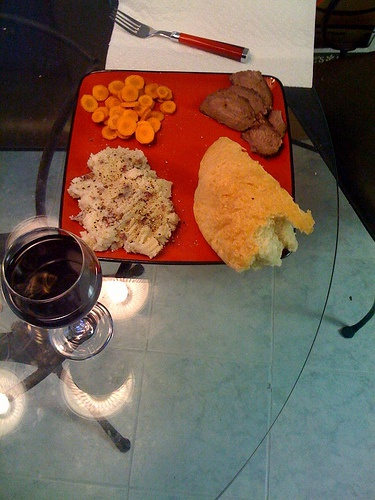Describe the objects in this image and their specific colors. I can see dining table in black and gray tones, wine glass in black, gray, and maroon tones, sandwich in black, orange, and olive tones, carrot in black, red, brown, and maroon tones, and fork in black, maroon, gray, and darkgray tones in this image. 